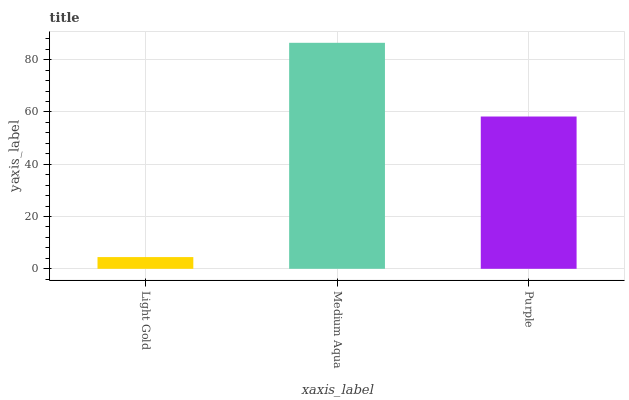Is Light Gold the minimum?
Answer yes or no. Yes. Is Medium Aqua the maximum?
Answer yes or no. Yes. Is Purple the minimum?
Answer yes or no. No. Is Purple the maximum?
Answer yes or no. No. Is Medium Aqua greater than Purple?
Answer yes or no. Yes. Is Purple less than Medium Aqua?
Answer yes or no. Yes. Is Purple greater than Medium Aqua?
Answer yes or no. No. Is Medium Aqua less than Purple?
Answer yes or no. No. Is Purple the high median?
Answer yes or no. Yes. Is Purple the low median?
Answer yes or no. Yes. Is Medium Aqua the high median?
Answer yes or no. No. Is Light Gold the low median?
Answer yes or no. No. 